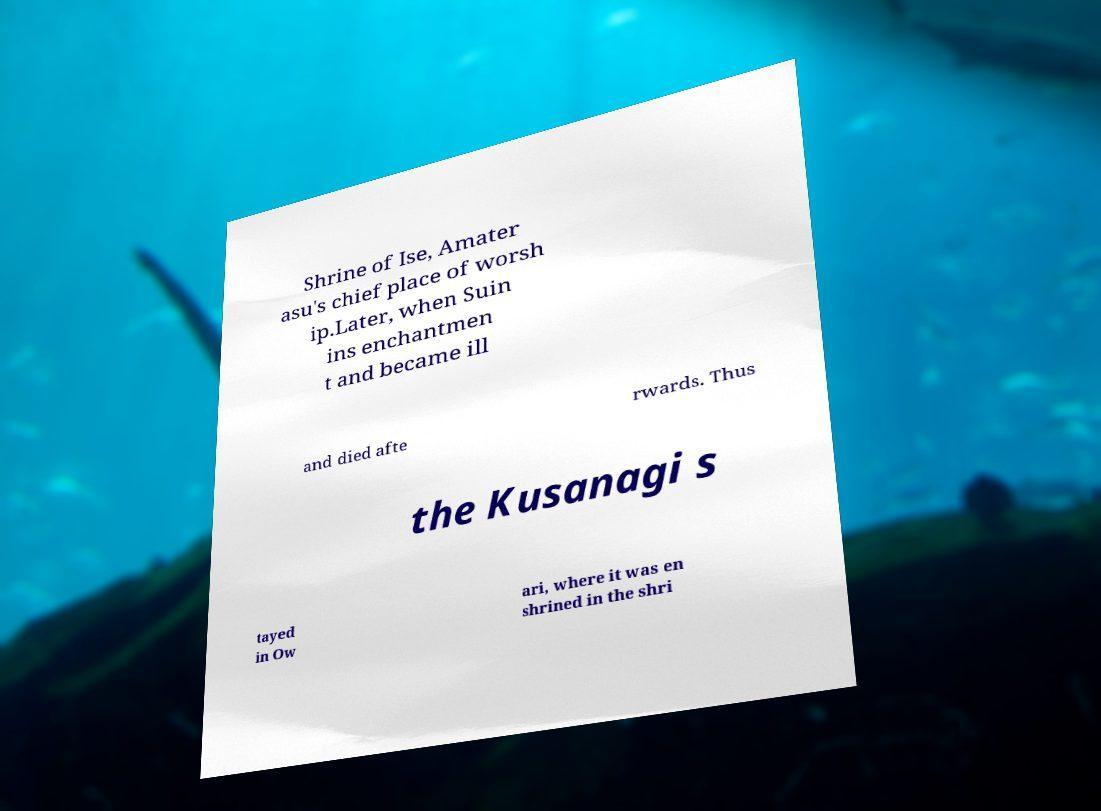What messages or text are displayed in this image? I need them in a readable, typed format. Shrine of Ise, Amater asu's chief place of worsh ip.Later, when Suin ins enchantmen t and became ill and died afte rwards. Thus the Kusanagi s tayed in Ow ari, where it was en shrined in the shri 